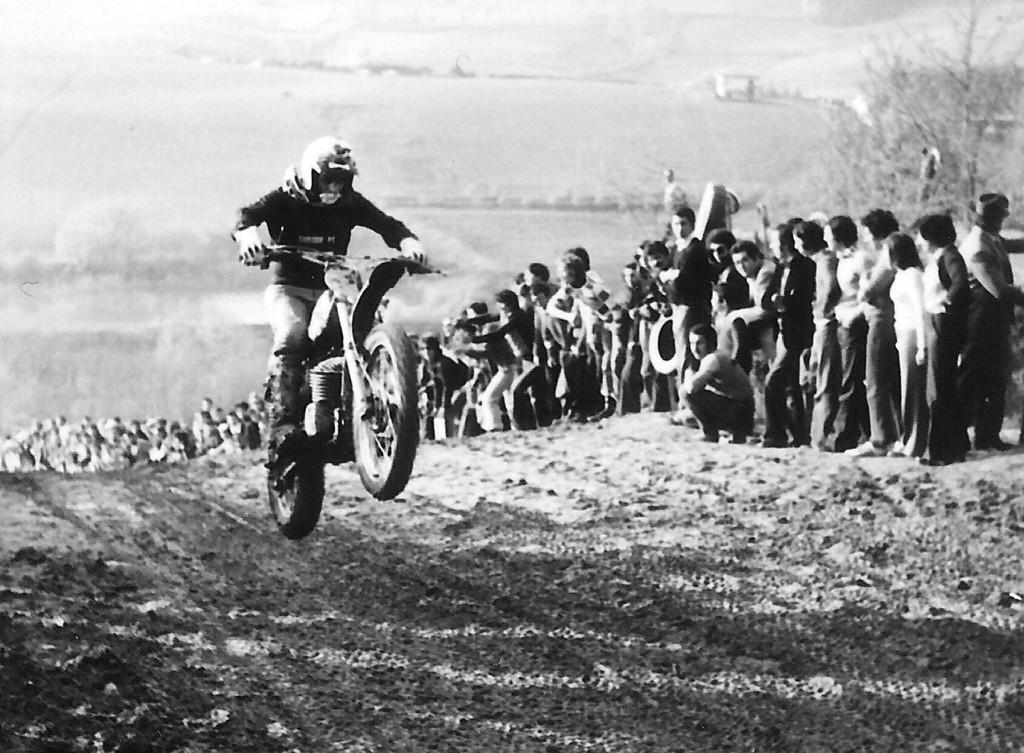What is happening in the image involving a group of people? There is a group of people in the image, but the specific activity they are engaged in is not mentioned in the facts. What is the motorcyclist doing in the image? The motorcyclist is racing and doing a wheelie in the image. What can be seen in the background of the image? There are trees in the background of the image. What is the motorcyclist using to learn how to balance during the wheelie? The facts do not mention anything about the motorcyclist learning or needing assistance to balance during the wheelie. 